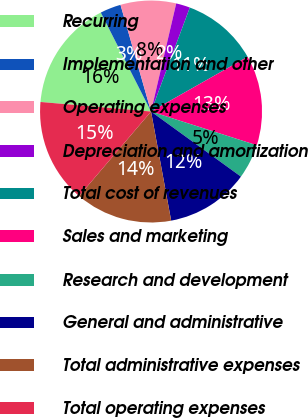Convert chart. <chart><loc_0><loc_0><loc_500><loc_500><pie_chart><fcel>Recurring<fcel>Implementation and other<fcel>Operating expenses<fcel>Depreciation and amortization<fcel>Total cost of revenues<fcel>Sales and marketing<fcel>Research and development<fcel>General and administrative<fcel>Total administrative expenses<fcel>Total operating expenses<nl><fcel>16.15%<fcel>3.04%<fcel>8.08%<fcel>2.04%<fcel>11.11%<fcel>13.12%<fcel>5.06%<fcel>12.12%<fcel>14.13%<fcel>15.14%<nl></chart> 